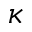Convert formula to latex. <formula><loc_0><loc_0><loc_500><loc_500>\kappa</formula> 